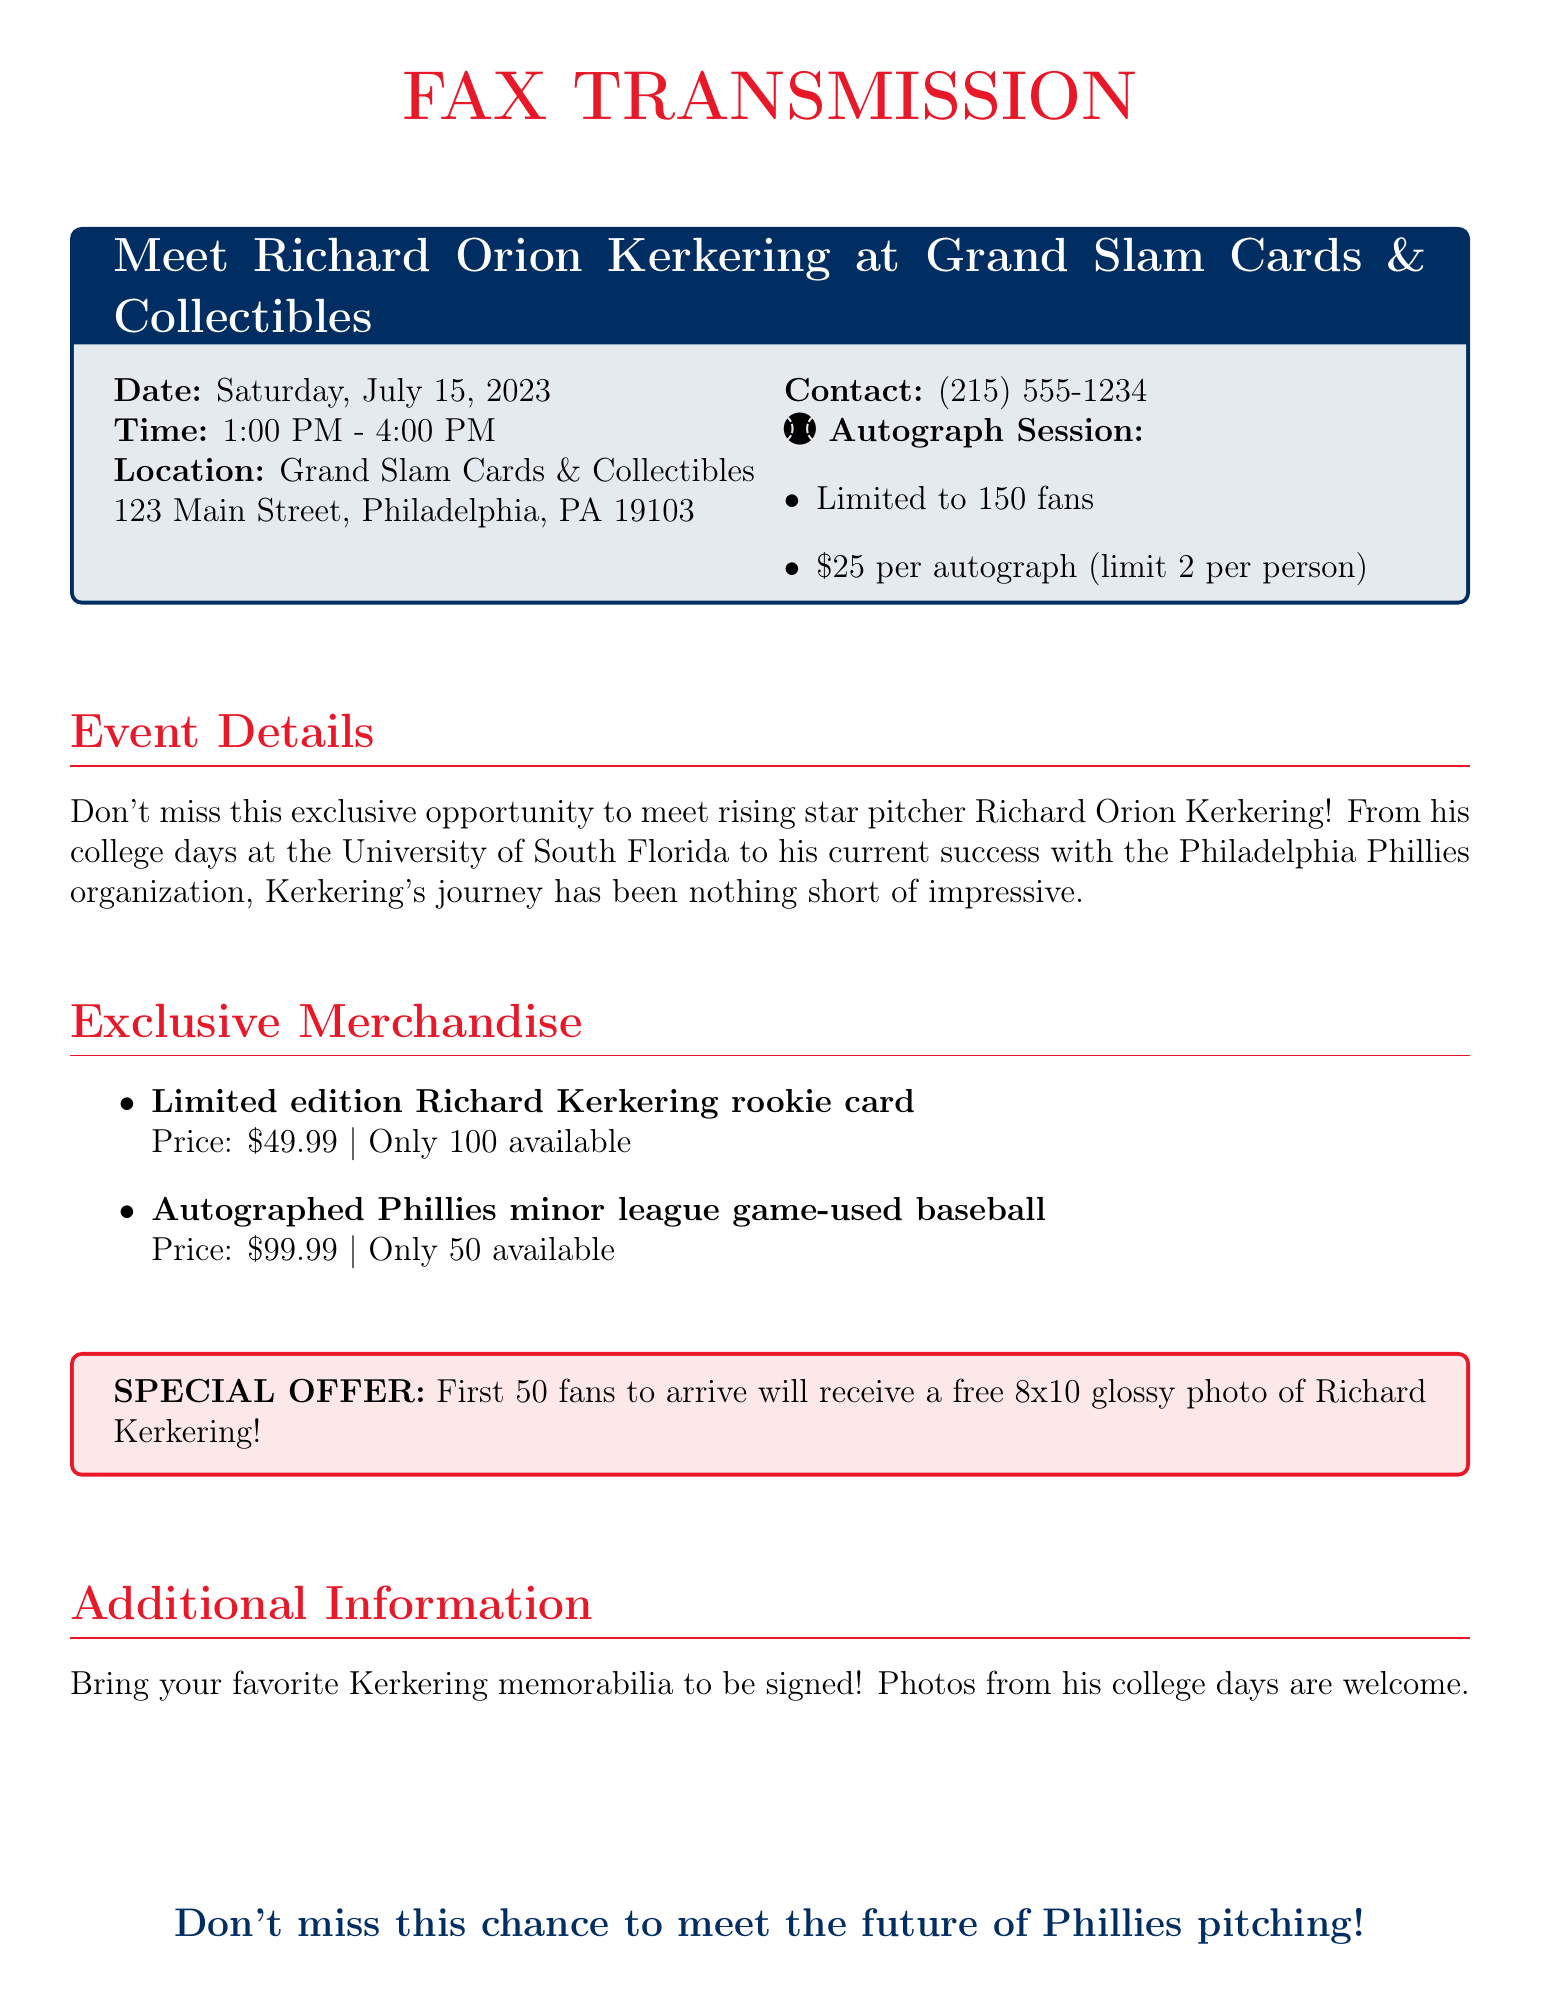What is the date of the event? The date of the event is explicitly stated in the document.
Answer: Saturday, July 15, 2023 What is the location of the meet-and-greet? The document provides the address where the event will take place.
Answer: Grand Slam Cards & Collectibles, 123 Main Street, Philadelphia, PA 19103 How much does each autograph cost? The cost of the autograph session is mentioned in the document.
Answer: $25 What is the limit of autographs per person? The document specifies how many autographs each person can request.
Answer: 2 How many limited edition rookie cards are available? It's stated how many rookie cards are for sale in the merchandise section.
Answer: 100 What special offer is provided to the first 50 fans? The document describes a special offer for early attendees.
Answer: A free 8x10 glossy photo of Richard Kerkering What is the price of the autographed game-used baseball? The price for the autographed baseball is clearly mentioned.
Answer: $99.99 What time does the event start? The start time of the event can be found in the document.
Answer: 1:00 PM What is Richard Kerkering's association with a college? The document mentions Richard Kerkering's college background.
Answer: University of South Florida 